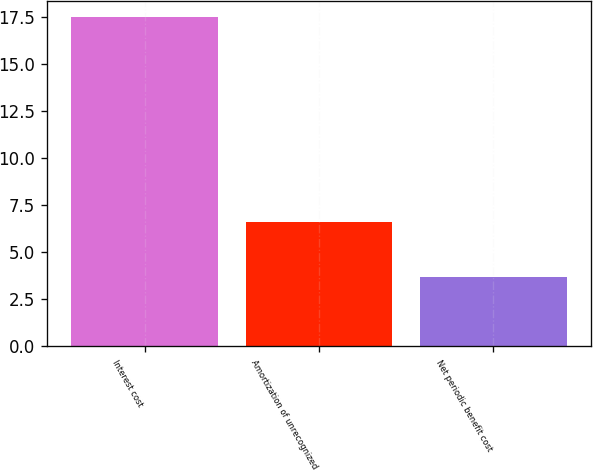Convert chart to OTSL. <chart><loc_0><loc_0><loc_500><loc_500><bar_chart><fcel>Interest cost<fcel>Amortization of unrecognized<fcel>Net periodic benefit cost<nl><fcel>17.5<fcel>6.6<fcel>3.7<nl></chart> 